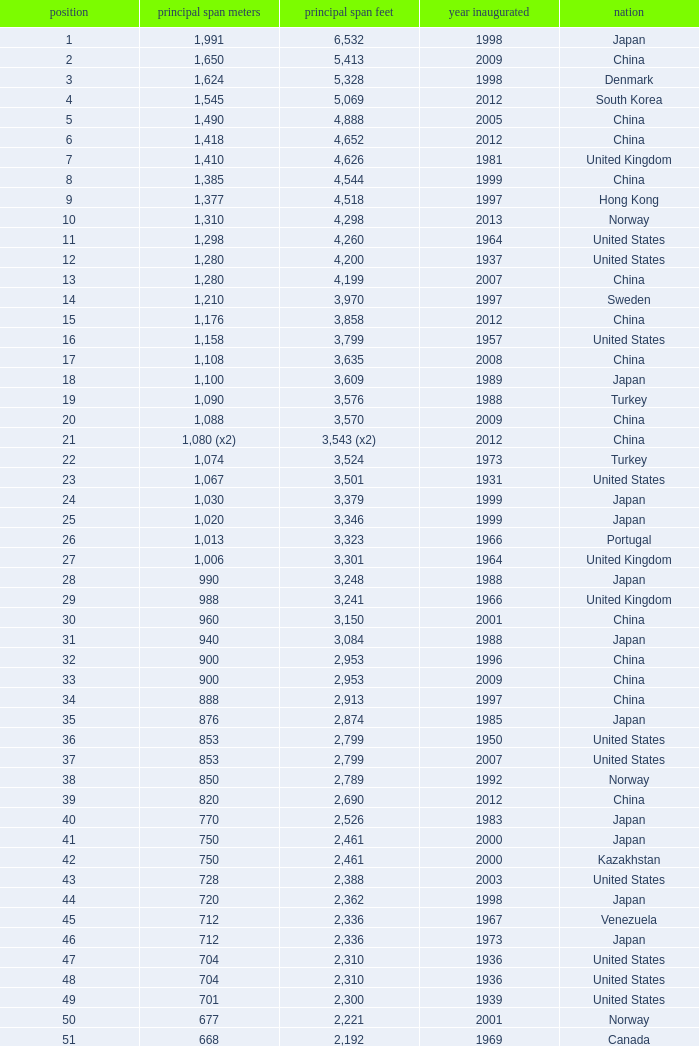What is the main span in feet from a year of 2009 or more recent with a rank less than 94 and 1,310 main span metres? 4298.0. 